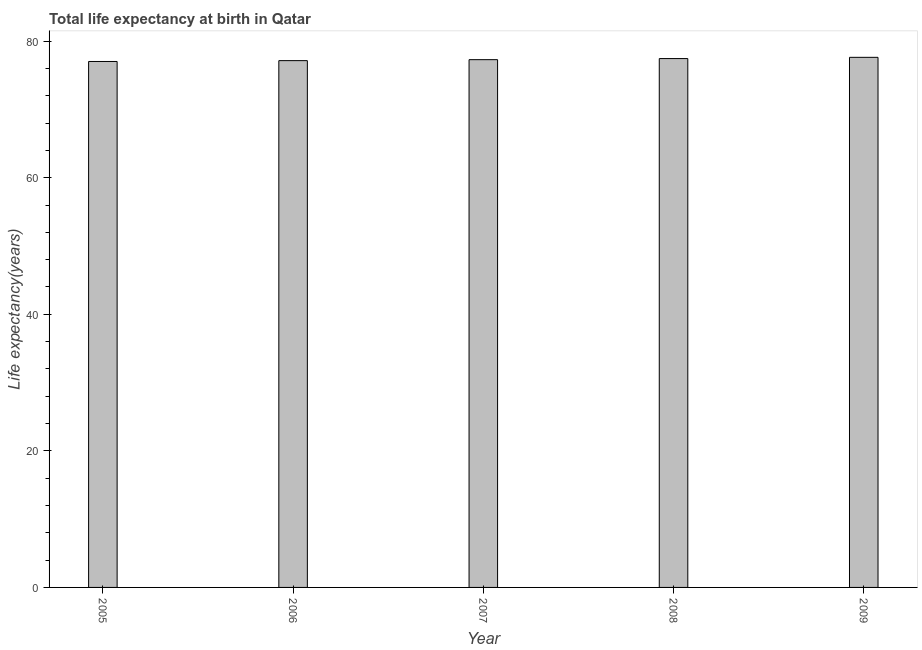What is the title of the graph?
Make the answer very short. Total life expectancy at birth in Qatar. What is the label or title of the Y-axis?
Your answer should be very brief. Life expectancy(years). What is the life expectancy at birth in 2006?
Ensure brevity in your answer.  77.15. Across all years, what is the maximum life expectancy at birth?
Make the answer very short. 77.63. Across all years, what is the minimum life expectancy at birth?
Ensure brevity in your answer.  77.02. What is the sum of the life expectancy at birth?
Keep it short and to the point. 386.53. What is the difference between the life expectancy at birth in 2008 and 2009?
Your answer should be compact. -0.18. What is the average life expectancy at birth per year?
Offer a very short reply. 77.31. What is the median life expectancy at birth?
Your answer should be very brief. 77.29. Do a majority of the years between 2008 and 2009 (inclusive) have life expectancy at birth greater than 68 years?
Make the answer very short. Yes. Is the life expectancy at birth in 2005 less than that in 2009?
Provide a short and direct response. Yes. Is the difference between the life expectancy at birth in 2006 and 2007 greater than the difference between any two years?
Keep it short and to the point. No. What is the difference between the highest and the second highest life expectancy at birth?
Offer a very short reply. 0.18. What is the difference between the highest and the lowest life expectancy at birth?
Offer a terse response. 0.61. In how many years, is the life expectancy at birth greater than the average life expectancy at birth taken over all years?
Your response must be concise. 2. How many bars are there?
Your answer should be compact. 5. Are all the bars in the graph horizontal?
Keep it short and to the point. No. What is the difference between two consecutive major ticks on the Y-axis?
Your answer should be very brief. 20. What is the Life expectancy(years) of 2005?
Give a very brief answer. 77.02. What is the Life expectancy(years) in 2006?
Provide a succinct answer. 77.15. What is the Life expectancy(years) in 2007?
Give a very brief answer. 77.29. What is the Life expectancy(years) of 2008?
Offer a very short reply. 77.45. What is the Life expectancy(years) in 2009?
Make the answer very short. 77.63. What is the difference between the Life expectancy(years) in 2005 and 2006?
Your answer should be very brief. -0.12. What is the difference between the Life expectancy(years) in 2005 and 2007?
Provide a succinct answer. -0.26. What is the difference between the Life expectancy(years) in 2005 and 2008?
Your answer should be compact. -0.43. What is the difference between the Life expectancy(years) in 2005 and 2009?
Your response must be concise. -0.61. What is the difference between the Life expectancy(years) in 2006 and 2007?
Your response must be concise. -0.14. What is the difference between the Life expectancy(years) in 2006 and 2008?
Offer a terse response. -0.3. What is the difference between the Life expectancy(years) in 2006 and 2009?
Make the answer very short. -0.48. What is the difference between the Life expectancy(years) in 2007 and 2008?
Ensure brevity in your answer.  -0.16. What is the difference between the Life expectancy(years) in 2007 and 2009?
Offer a very short reply. -0.34. What is the difference between the Life expectancy(years) in 2008 and 2009?
Make the answer very short. -0.18. What is the ratio of the Life expectancy(years) in 2005 to that in 2006?
Offer a terse response. 1. What is the ratio of the Life expectancy(years) in 2005 to that in 2009?
Keep it short and to the point. 0.99. What is the ratio of the Life expectancy(years) in 2006 to that in 2007?
Your answer should be compact. 1. What is the ratio of the Life expectancy(years) in 2006 to that in 2009?
Provide a short and direct response. 0.99. What is the ratio of the Life expectancy(years) in 2007 to that in 2008?
Provide a succinct answer. 1. 